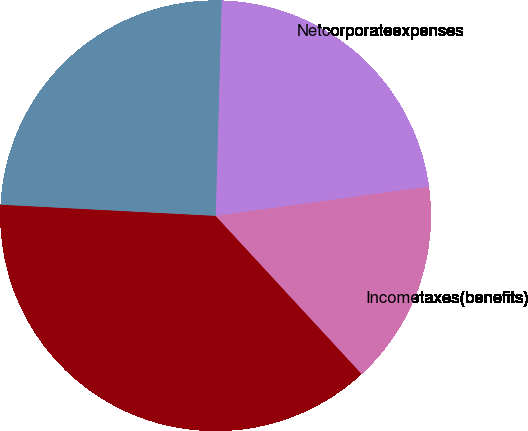Convert chart to OTSL. <chart><loc_0><loc_0><loc_500><loc_500><pie_chart><fcel>Corporate expenses (excluding<fcel>Incometaxes(benefits)<fcel>Netcorporateexpenses<fcel>Unnamed: 3<nl><fcel>37.69%<fcel>15.31%<fcel>22.38%<fcel>24.62%<nl></chart> 